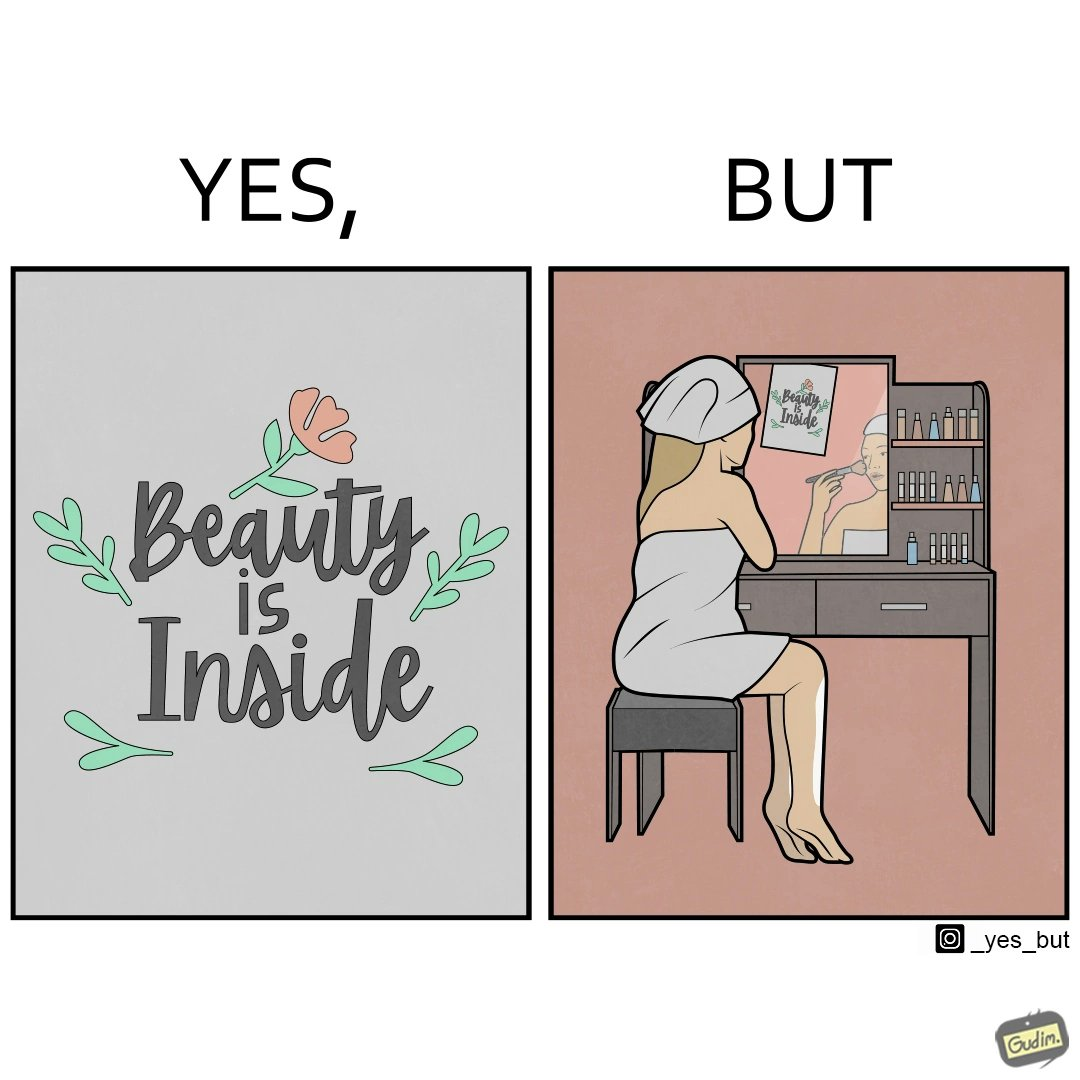What do you see in each half of this image? In the left part of the image: The image shows a text in beautiful font with flowers drawn around it. The text says "Beauty Is Inside". In the right part of the image: The image shows a woman applying makeup after shower by looking at herself in the dressing mirror. A piece of paper that says "Beauty is Inside" is clipped to the top of the mirror. 